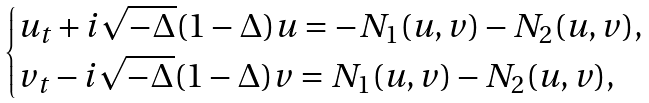<formula> <loc_0><loc_0><loc_500><loc_500>\begin{cases} u _ { t } + i \sqrt { - \Delta } ( 1 - \Delta ) u = - N _ { 1 } ( u , v ) - N _ { 2 } ( u , v ) , \\ v _ { t } - i \sqrt { - \Delta } ( 1 - \Delta ) v = N _ { 1 } ( u , v ) - N _ { 2 } ( u , v ) , \end{cases}</formula> 